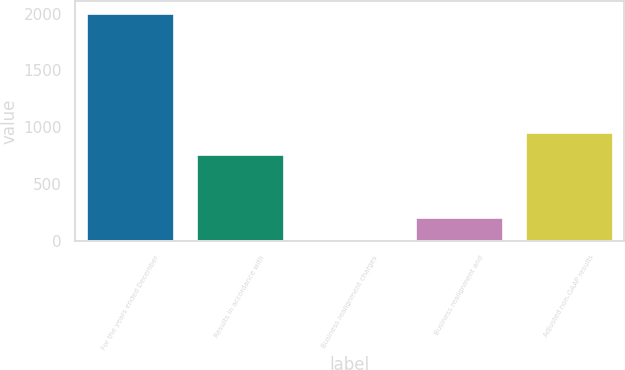<chart> <loc_0><loc_0><loc_500><loc_500><bar_chart><fcel>For the years ended December<fcel>Results in accordance with<fcel>Business realignment charges<fcel>Business realignment and<fcel>Adjusted non-GAAP results<nl><fcel>2009<fcel>761.6<fcel>10.1<fcel>209.99<fcel>961.49<nl></chart> 